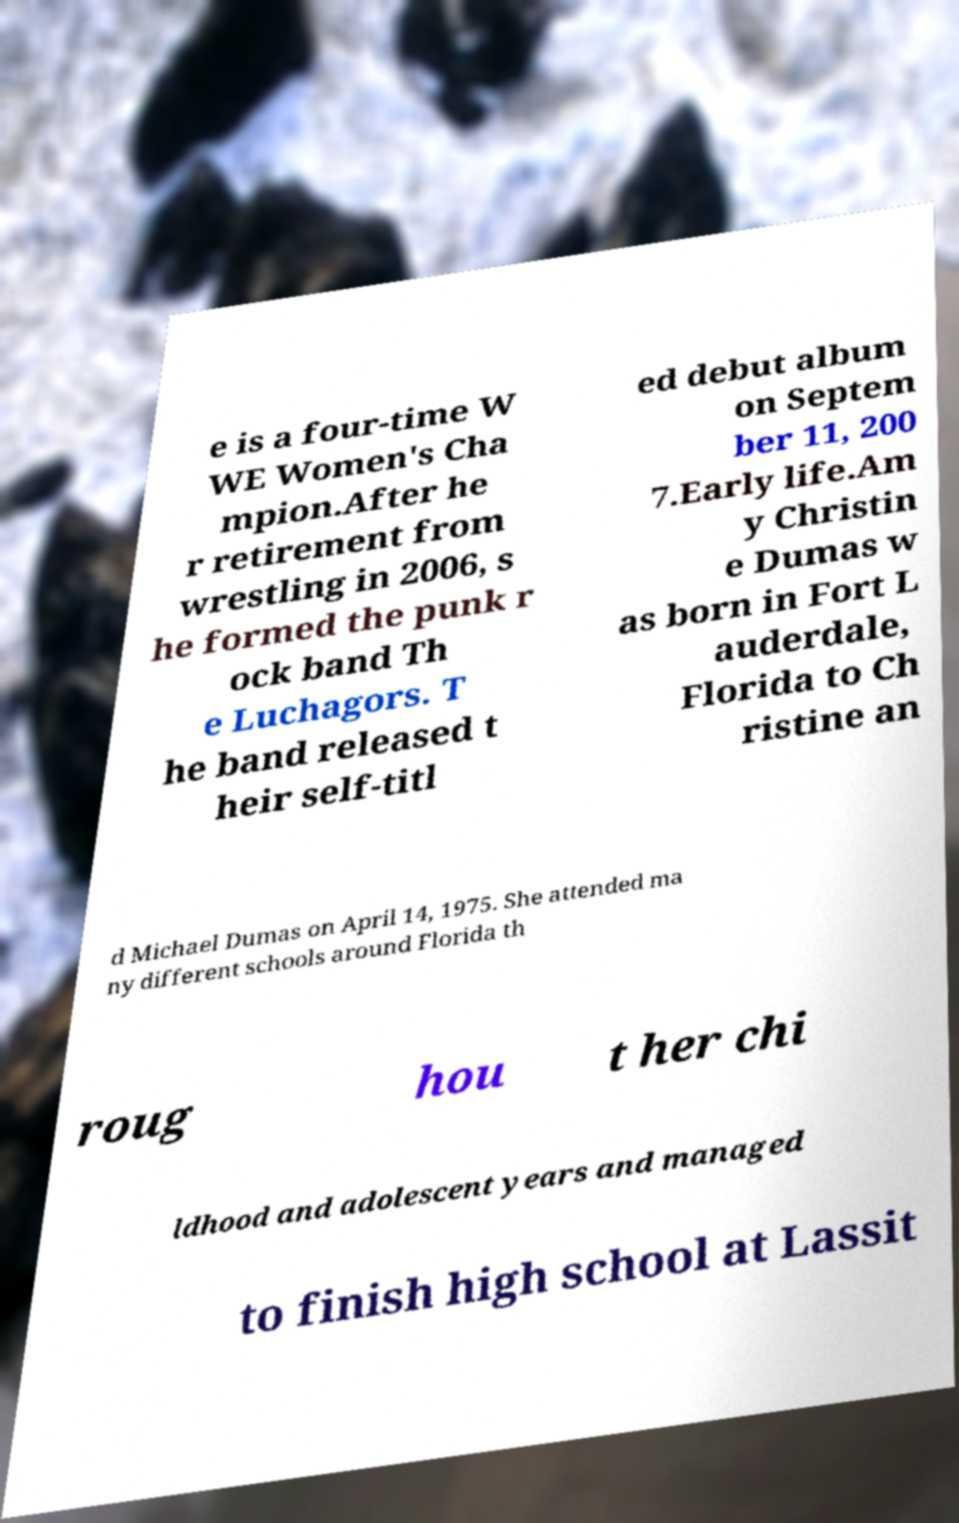There's text embedded in this image that I need extracted. Can you transcribe it verbatim? e is a four-time W WE Women's Cha mpion.After he r retirement from wrestling in 2006, s he formed the punk r ock band Th e Luchagors. T he band released t heir self-titl ed debut album on Septem ber 11, 200 7.Early life.Am y Christin e Dumas w as born in Fort L auderdale, Florida to Ch ristine an d Michael Dumas on April 14, 1975. She attended ma ny different schools around Florida th roug hou t her chi ldhood and adolescent years and managed to finish high school at Lassit 